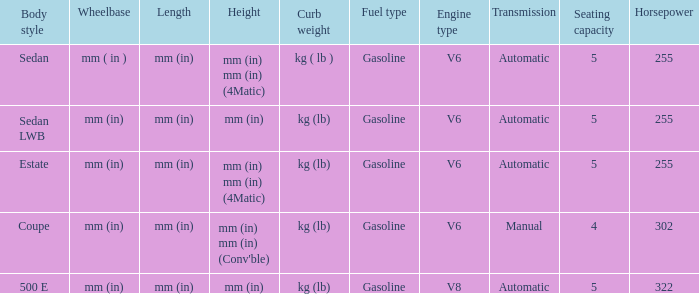What's the length of the model with 500 E body style? Mm (in). 